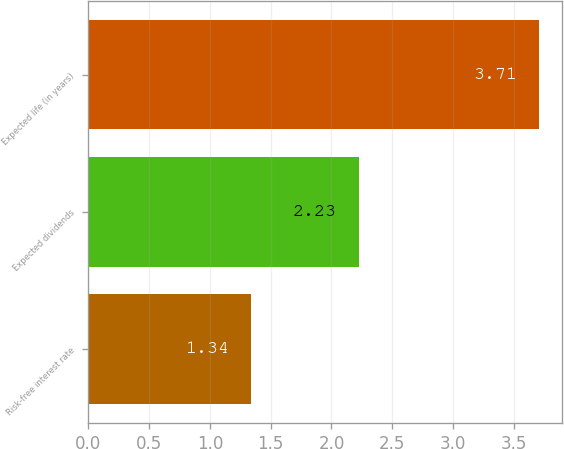<chart> <loc_0><loc_0><loc_500><loc_500><bar_chart><fcel>Risk-free interest rate<fcel>Expected dividends<fcel>Expected life (in years)<nl><fcel>1.34<fcel>2.23<fcel>3.71<nl></chart> 